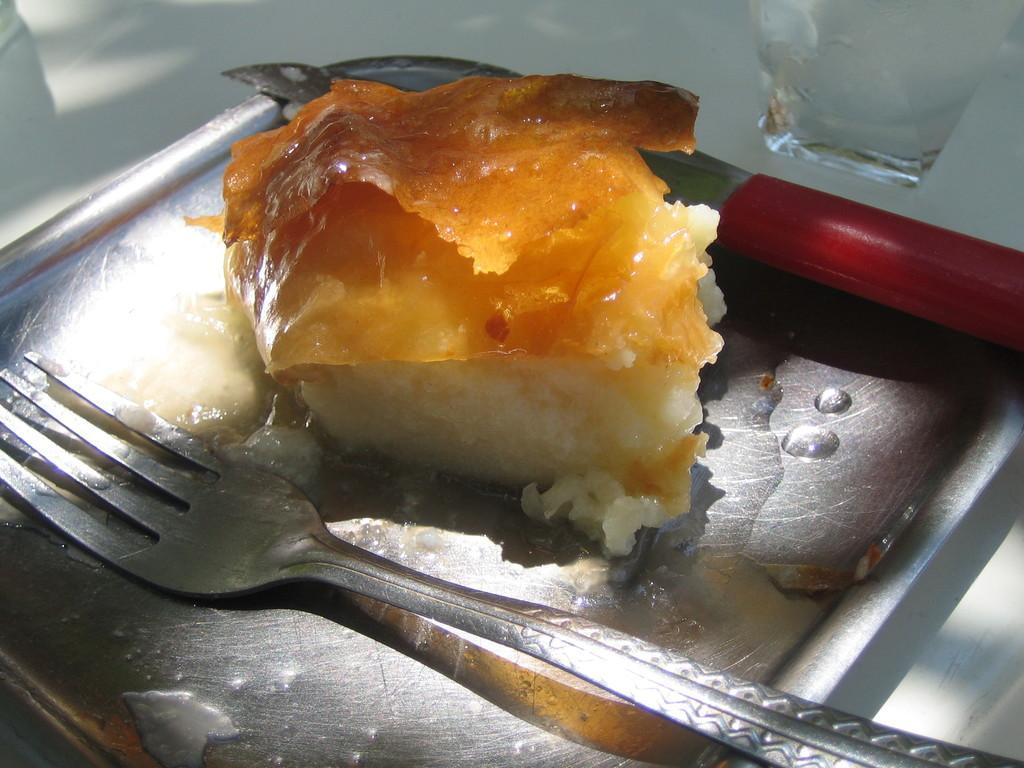Describe this image in one or two sentences. In this image we can see a food item on the plate, also we can see fork, knife, and a glass. 